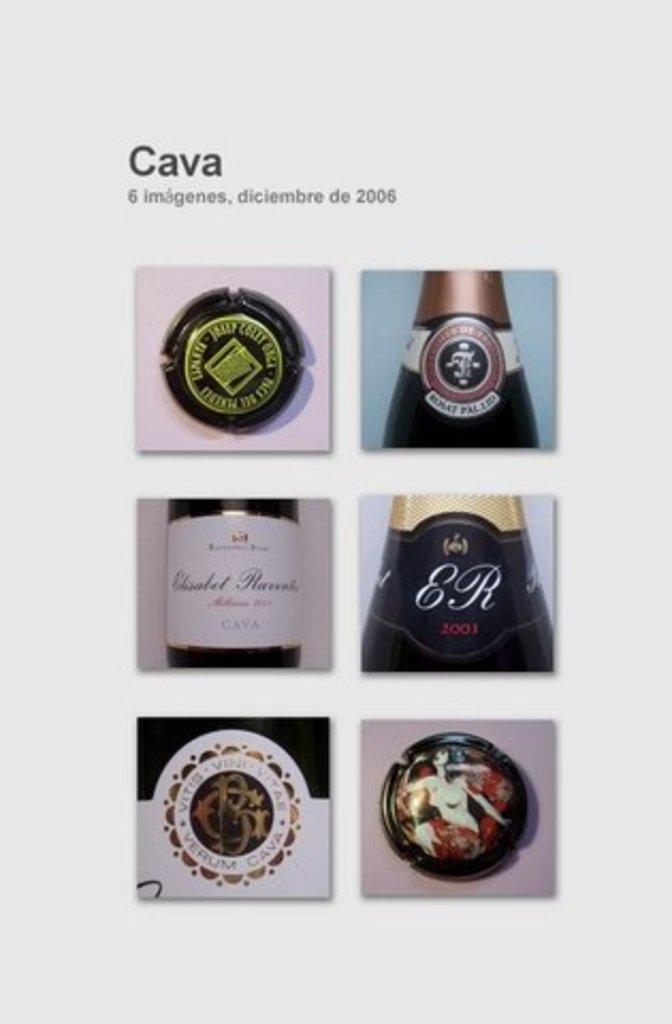What does it say on this bottle?
Your answer should be very brief. Er. How many pictures are there?
Offer a terse response. 6. 